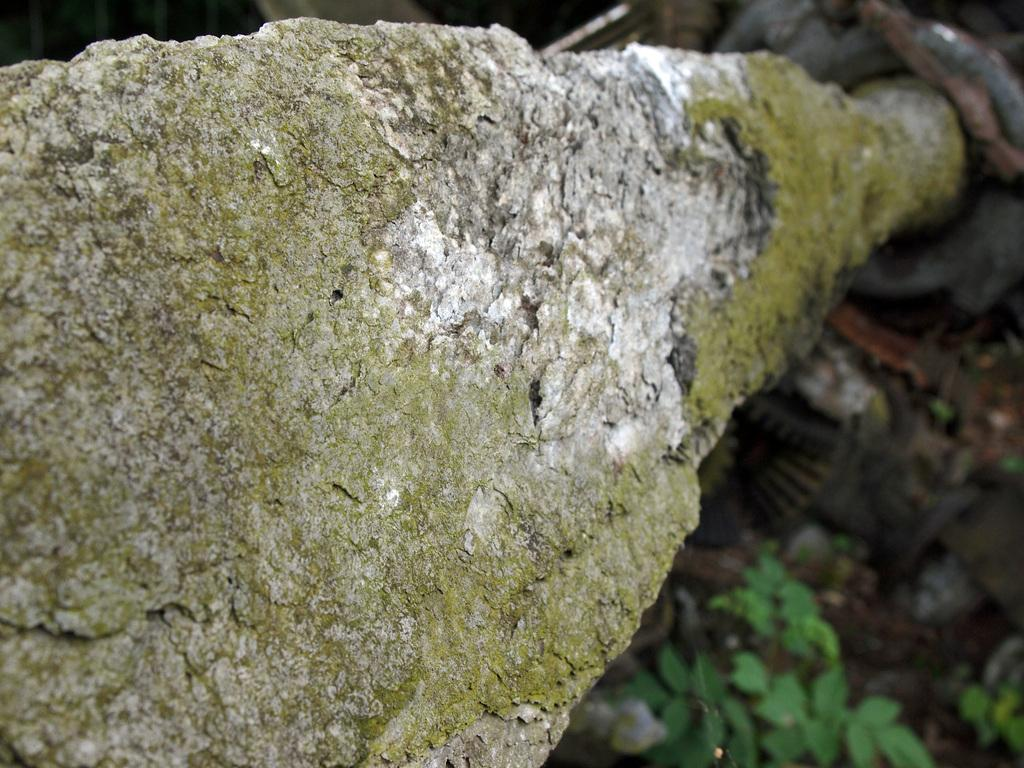What is the focus of the image? The image is zoomed in, so the focus is on a specific area or object. What can be seen on the left side of the image? There is an object that appears to be the trunk of a tree on the left side of the image. What type of vegetation is visible in the background of the image? There are plants visible in the background of the image. What else can be seen in the background of the image? There are other unspecified objects in the background of the image. How many mice are sitting on the hope of beef in the image? There are no mice or beef present in the image; it features a tree trunk and plants in the background. 